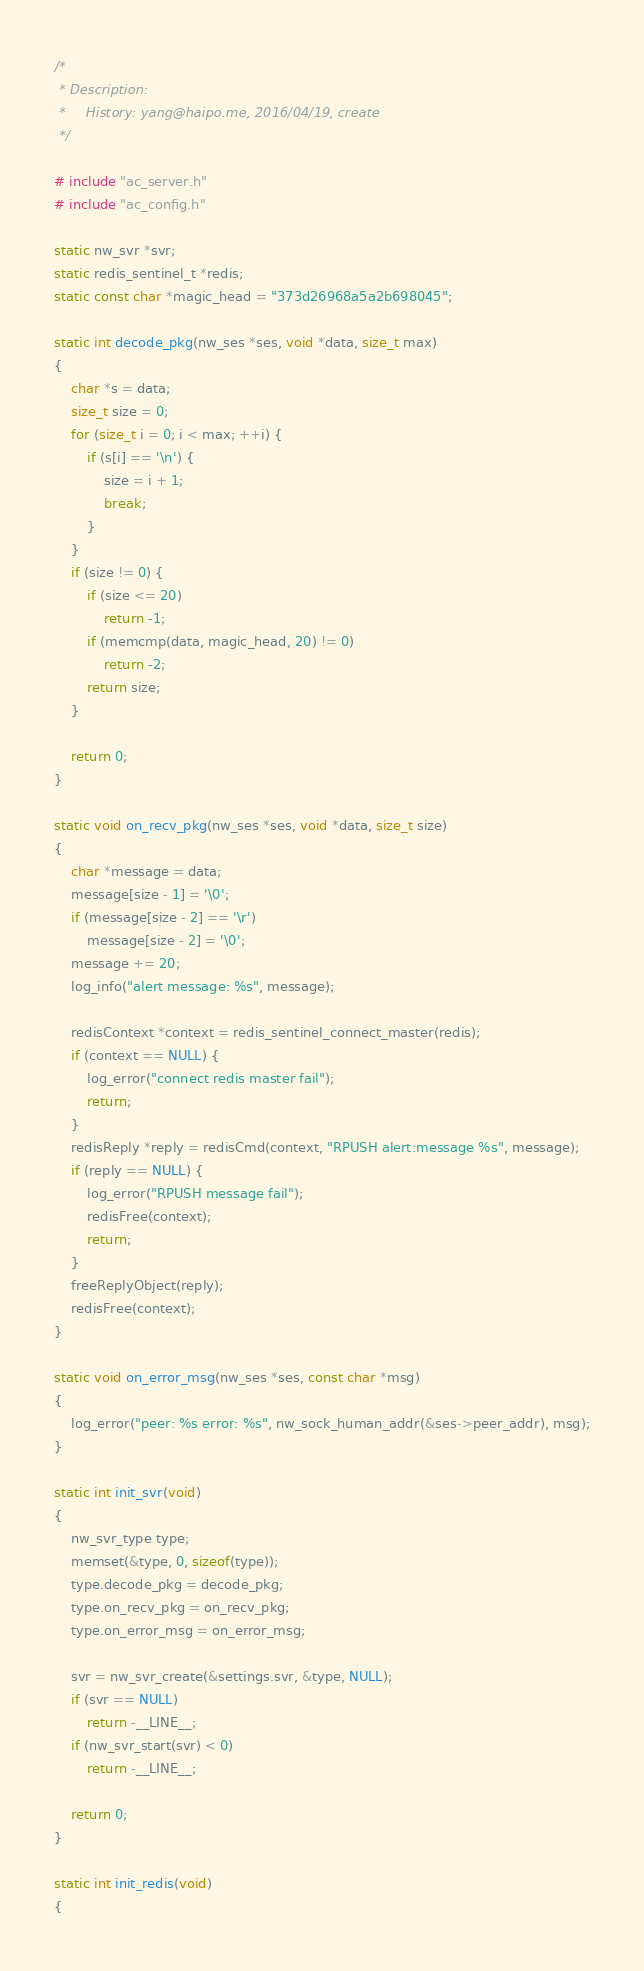<code> <loc_0><loc_0><loc_500><loc_500><_C_>/*
 * Description: 
 *     History: yang@haipo.me, 2016/04/19, create
 */

# include "ac_server.h"
# include "ac_config.h"

static nw_svr *svr;
static redis_sentinel_t *redis;
static const char *magic_head = "373d26968a5a2b698045";

static int decode_pkg(nw_ses *ses, void *data, size_t max)
{
    char *s = data;
    size_t size = 0;
    for (size_t i = 0; i < max; ++i) {
        if (s[i] == '\n') {
            size = i + 1;
            break;
        }
    }
    if (size != 0) {
        if (size <= 20)
            return -1;
        if (memcmp(data, magic_head, 20) != 0)
            return -2;
        return size;
    }

    return 0;
}

static void on_recv_pkg(nw_ses *ses, void *data, size_t size)
{
    char *message = data;
    message[size - 1] = '\0';
    if (message[size - 2] == '\r')
        message[size - 2] = '\0';
    message += 20;
    log_info("alert message: %s", message);

    redisContext *context = redis_sentinel_connect_master(redis);
    if (context == NULL) {
        log_error("connect redis master fail");
        return;
    }
    redisReply *reply = redisCmd(context, "RPUSH alert:message %s", message);
    if (reply == NULL) {
        log_error("RPUSH message fail");
        redisFree(context);
        return;
    }
    freeReplyObject(reply);
    redisFree(context);
}

static void on_error_msg(nw_ses *ses, const char *msg)
{
    log_error("peer: %s error: %s", nw_sock_human_addr(&ses->peer_addr), msg);
}

static int init_svr(void)
{
    nw_svr_type type;
    memset(&type, 0, sizeof(type));
    type.decode_pkg = decode_pkg;
    type.on_recv_pkg = on_recv_pkg;
    type.on_error_msg = on_error_msg;

    svr = nw_svr_create(&settings.svr, &type, NULL);
    if (svr == NULL)
        return -__LINE__;
    if (nw_svr_start(svr) < 0)
        return -__LINE__;

    return 0;
}

static int init_redis(void)
{</code> 